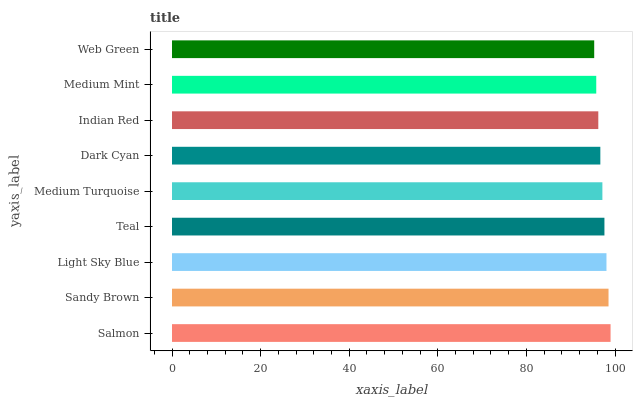Is Web Green the minimum?
Answer yes or no. Yes. Is Salmon the maximum?
Answer yes or no. Yes. Is Sandy Brown the minimum?
Answer yes or no. No. Is Sandy Brown the maximum?
Answer yes or no. No. Is Salmon greater than Sandy Brown?
Answer yes or no. Yes. Is Sandy Brown less than Salmon?
Answer yes or no. Yes. Is Sandy Brown greater than Salmon?
Answer yes or no. No. Is Salmon less than Sandy Brown?
Answer yes or no. No. Is Medium Turquoise the high median?
Answer yes or no. Yes. Is Medium Turquoise the low median?
Answer yes or no. Yes. Is Web Green the high median?
Answer yes or no. No. Is Web Green the low median?
Answer yes or no. No. 